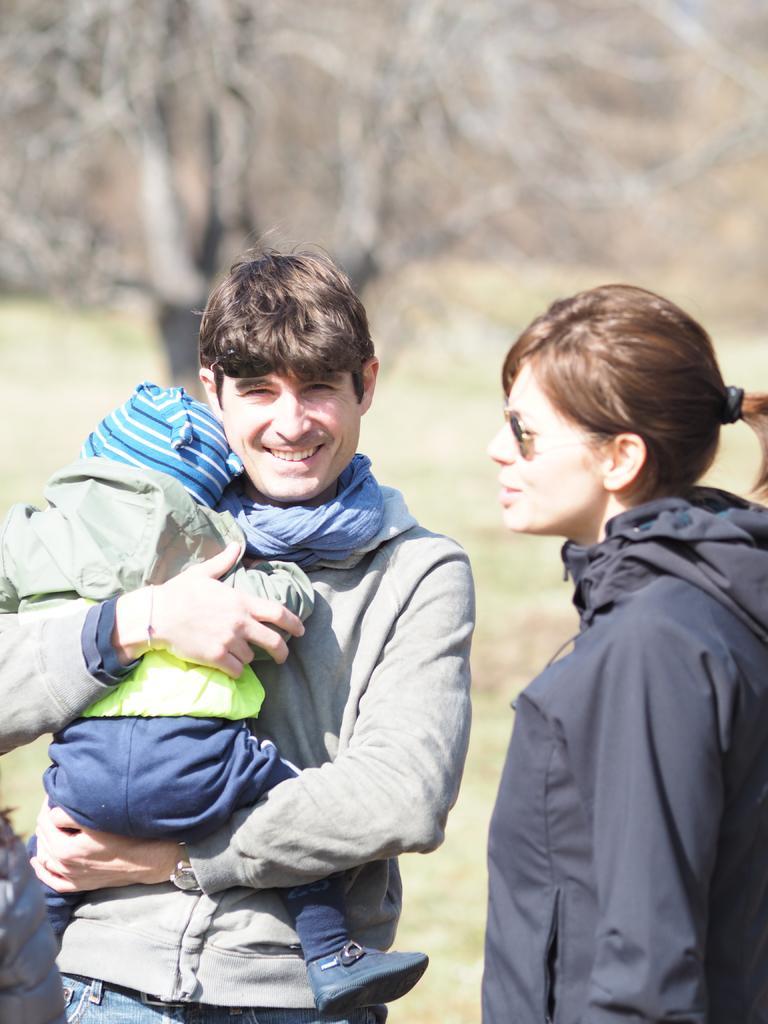Could you give a brief overview of what you see in this image? In this image I can see three people with different color dresses. In the background I can see the tree. I can see the background is blurred. 